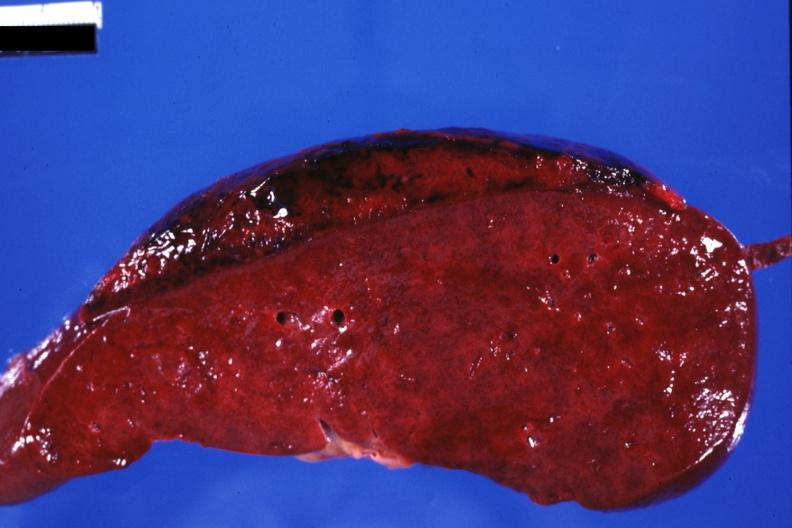s foot present?
Answer the question using a single word or phrase. No 